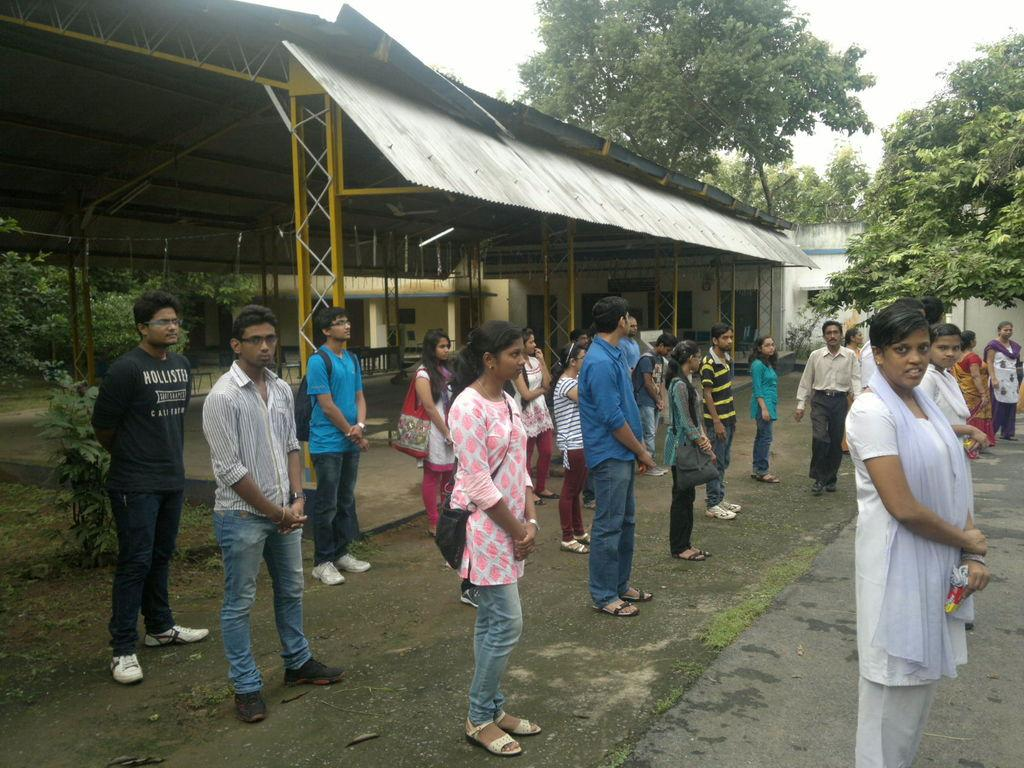How many people are in the image? There is a group of people in the image, but the exact number is not specified. What are the people in the image doing? The people are standing in the image. What can be seen in the background of the image? There are trees, metal rods, a shed, and houses in the background of the image. What type of noise can be heard coming from the truck in the image? There is no truck present in the image, so it is not possible to determine what, if any, noise might be heard. 